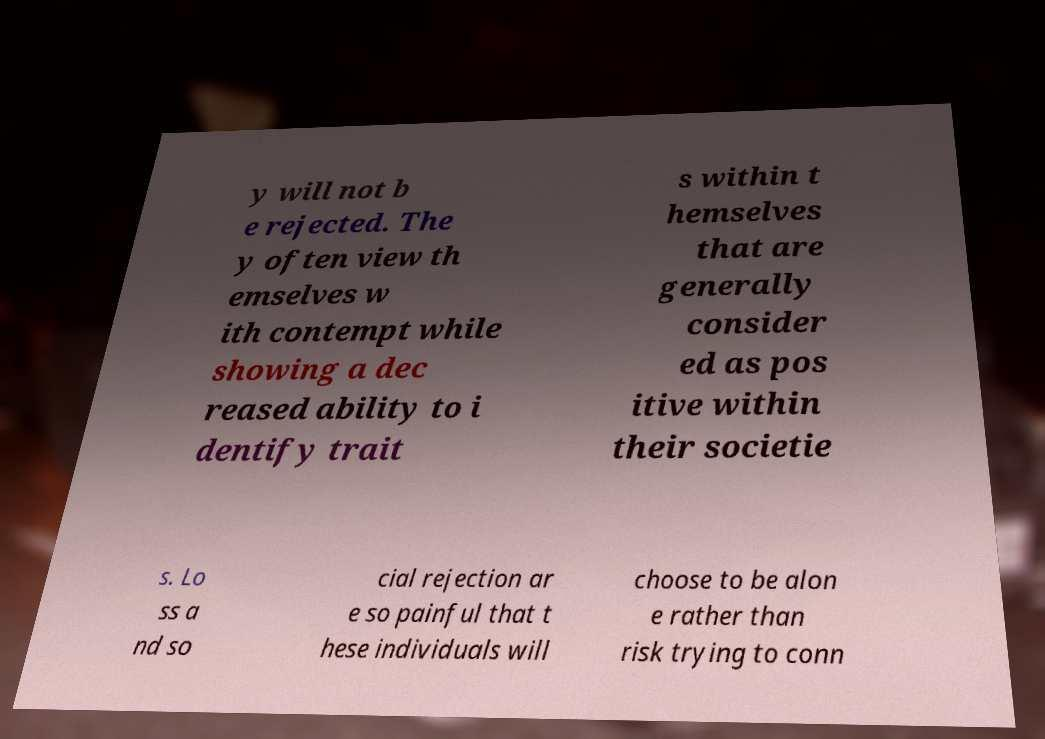There's text embedded in this image that I need extracted. Can you transcribe it verbatim? y will not b e rejected. The y often view th emselves w ith contempt while showing a dec reased ability to i dentify trait s within t hemselves that are generally consider ed as pos itive within their societie s. Lo ss a nd so cial rejection ar e so painful that t hese individuals will choose to be alon e rather than risk trying to conn 